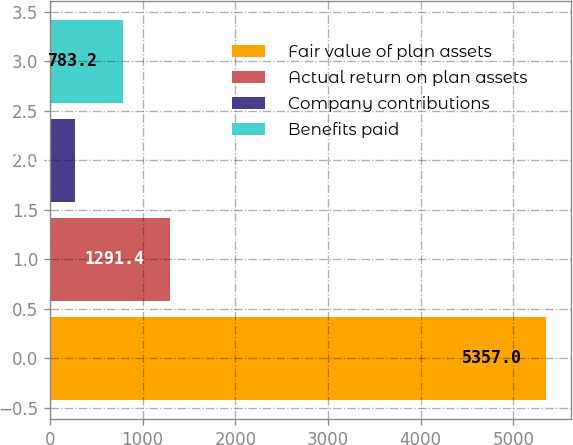Convert chart. <chart><loc_0><loc_0><loc_500><loc_500><bar_chart><fcel>Fair value of plan assets<fcel>Actual return on plan assets<fcel>Company contributions<fcel>Benefits paid<nl><fcel>5357<fcel>1291.4<fcel>275<fcel>783.2<nl></chart> 